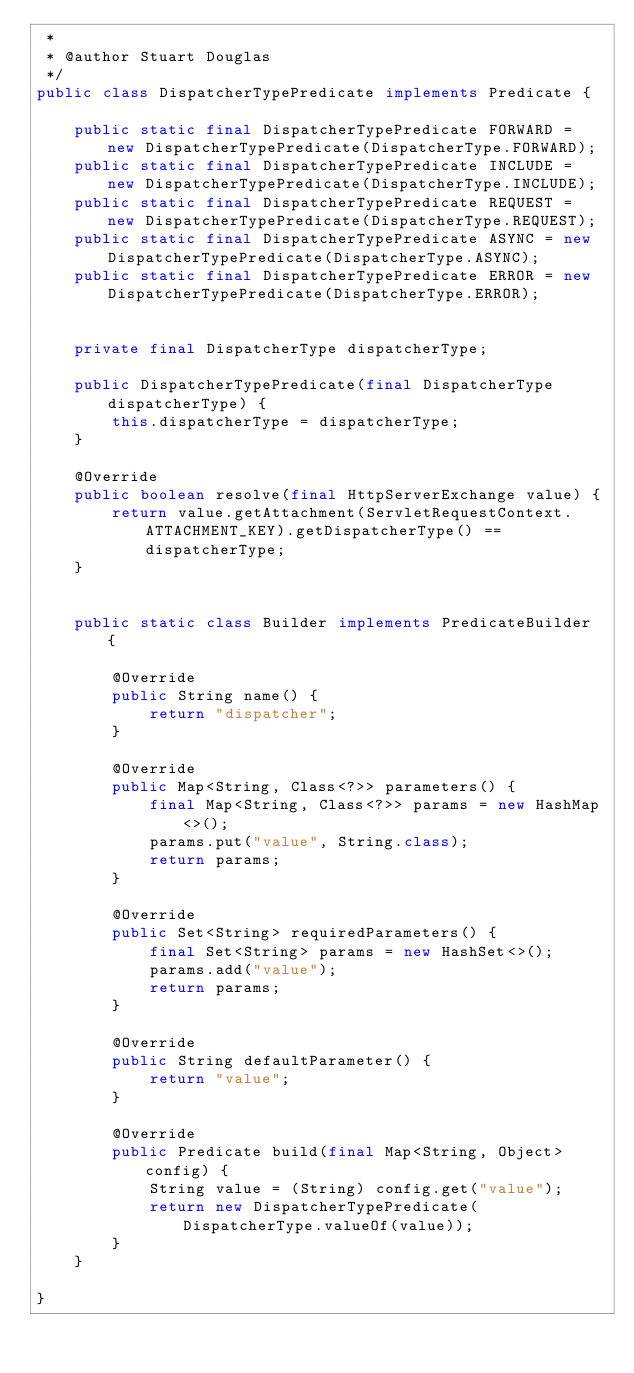<code> <loc_0><loc_0><loc_500><loc_500><_Java_> *
 * @author Stuart Douglas
 */
public class DispatcherTypePredicate implements Predicate {

    public static final DispatcherTypePredicate FORWARD = new DispatcherTypePredicate(DispatcherType.FORWARD);
    public static final DispatcherTypePredicate INCLUDE = new DispatcherTypePredicate(DispatcherType.INCLUDE);
    public static final DispatcherTypePredicate REQUEST = new DispatcherTypePredicate(DispatcherType.REQUEST);
    public static final DispatcherTypePredicate ASYNC = new DispatcherTypePredicate(DispatcherType.ASYNC);
    public static final DispatcherTypePredicate ERROR = new DispatcherTypePredicate(DispatcherType.ERROR);


    private final DispatcherType dispatcherType;

    public DispatcherTypePredicate(final DispatcherType dispatcherType) {
        this.dispatcherType = dispatcherType;
    }

    @Override
    public boolean resolve(final HttpServerExchange value) {
        return value.getAttachment(ServletRequestContext.ATTACHMENT_KEY).getDispatcherType() == dispatcherType;
    }


    public static class Builder implements PredicateBuilder {

        @Override
        public String name() {
            return "dispatcher";
        }

        @Override
        public Map<String, Class<?>> parameters() {
            final Map<String, Class<?>> params = new HashMap<>();
            params.put("value", String.class);
            return params;
        }

        @Override
        public Set<String> requiredParameters() {
            final Set<String> params = new HashSet<>();
            params.add("value");
            return params;
        }

        @Override
        public String defaultParameter() {
            return "value";
        }

        @Override
        public Predicate build(final Map<String, Object> config) {
            String value = (String) config.get("value");
            return new DispatcherTypePredicate(DispatcherType.valueOf(value));
        }
    }

}
</code> 